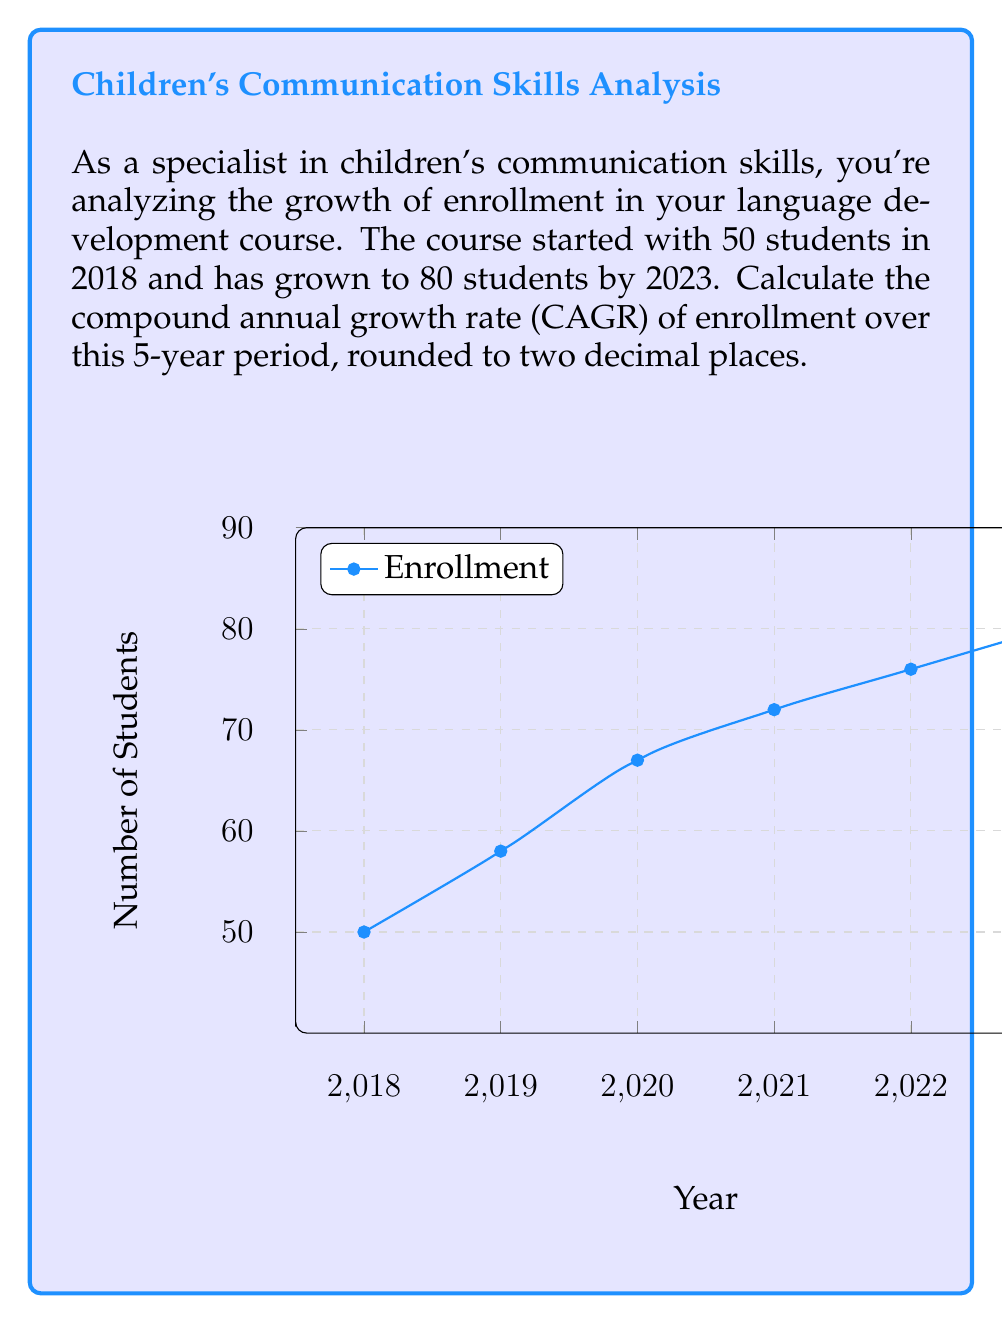Help me with this question. To calculate the Compound Annual Growth Rate (CAGR), we use the formula:

$$ CAGR = \left(\frac{Ending Value}{Beginning Value}\right)^{\frac{1}{n}} - 1 $$

Where:
- Ending Value = 80 students
- Beginning Value = 50 students
- n = 5 years

Let's plug these values into the formula:

$$ CAGR = \left(\frac{80}{50}\right)^{\frac{1}{5}} - 1 $$

Now, let's solve step-by-step:

1) First, calculate the fraction inside the parentheses:
   $\frac{80}{50} = 1.6$

2) Now, our equation looks like:
   $$ CAGR = (1.6)^{\frac{1}{5}} - 1 $$

3) Calculate the fifth root of 1.6:
   $(1.6)^{\frac{1}{5}} \approx 1.0986$

4) Subtract 1:
   $1.0986 - 1 = 0.0986$

5) Convert to a percentage by multiplying by 100:
   $0.0986 * 100 = 9.86\%$

6) Round to two decimal places:
   $9.86\%$

Therefore, the compound annual growth rate is 9.86%.
Answer: 9.86% 